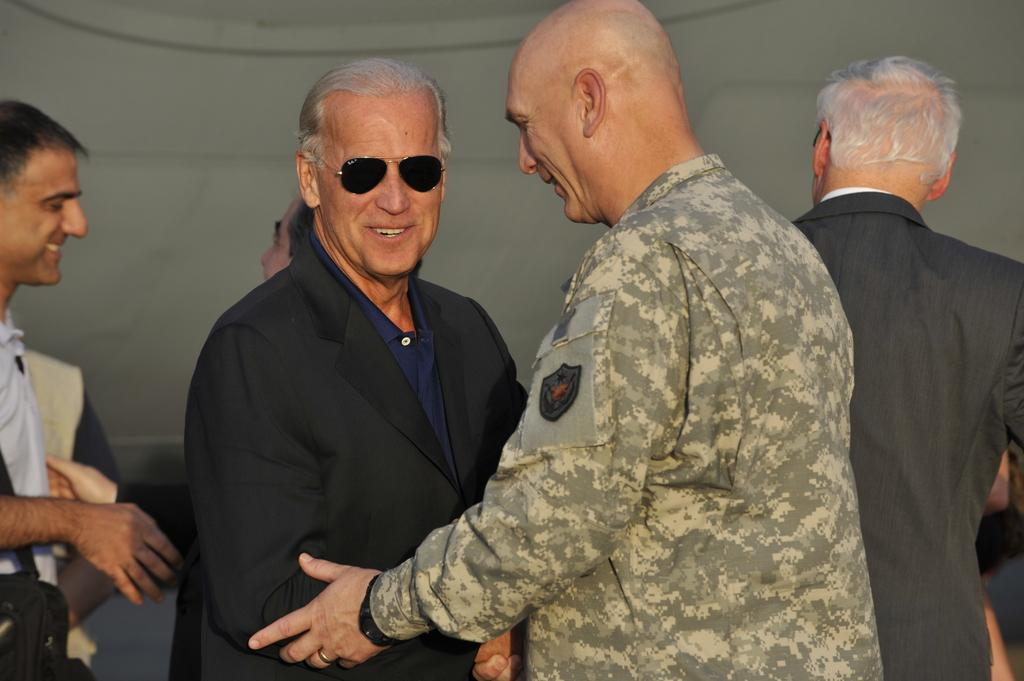What is happening in the image? There are people standing in the image. Can you describe the clothing of the people? The people are wearing different color dresses. What is the color of the background in the image? The background of the image is in grey color. What type of flower is being ordered by the people in the image? There is no flower or order present in the image; it only shows people standing in different color dresses with a grey background. 